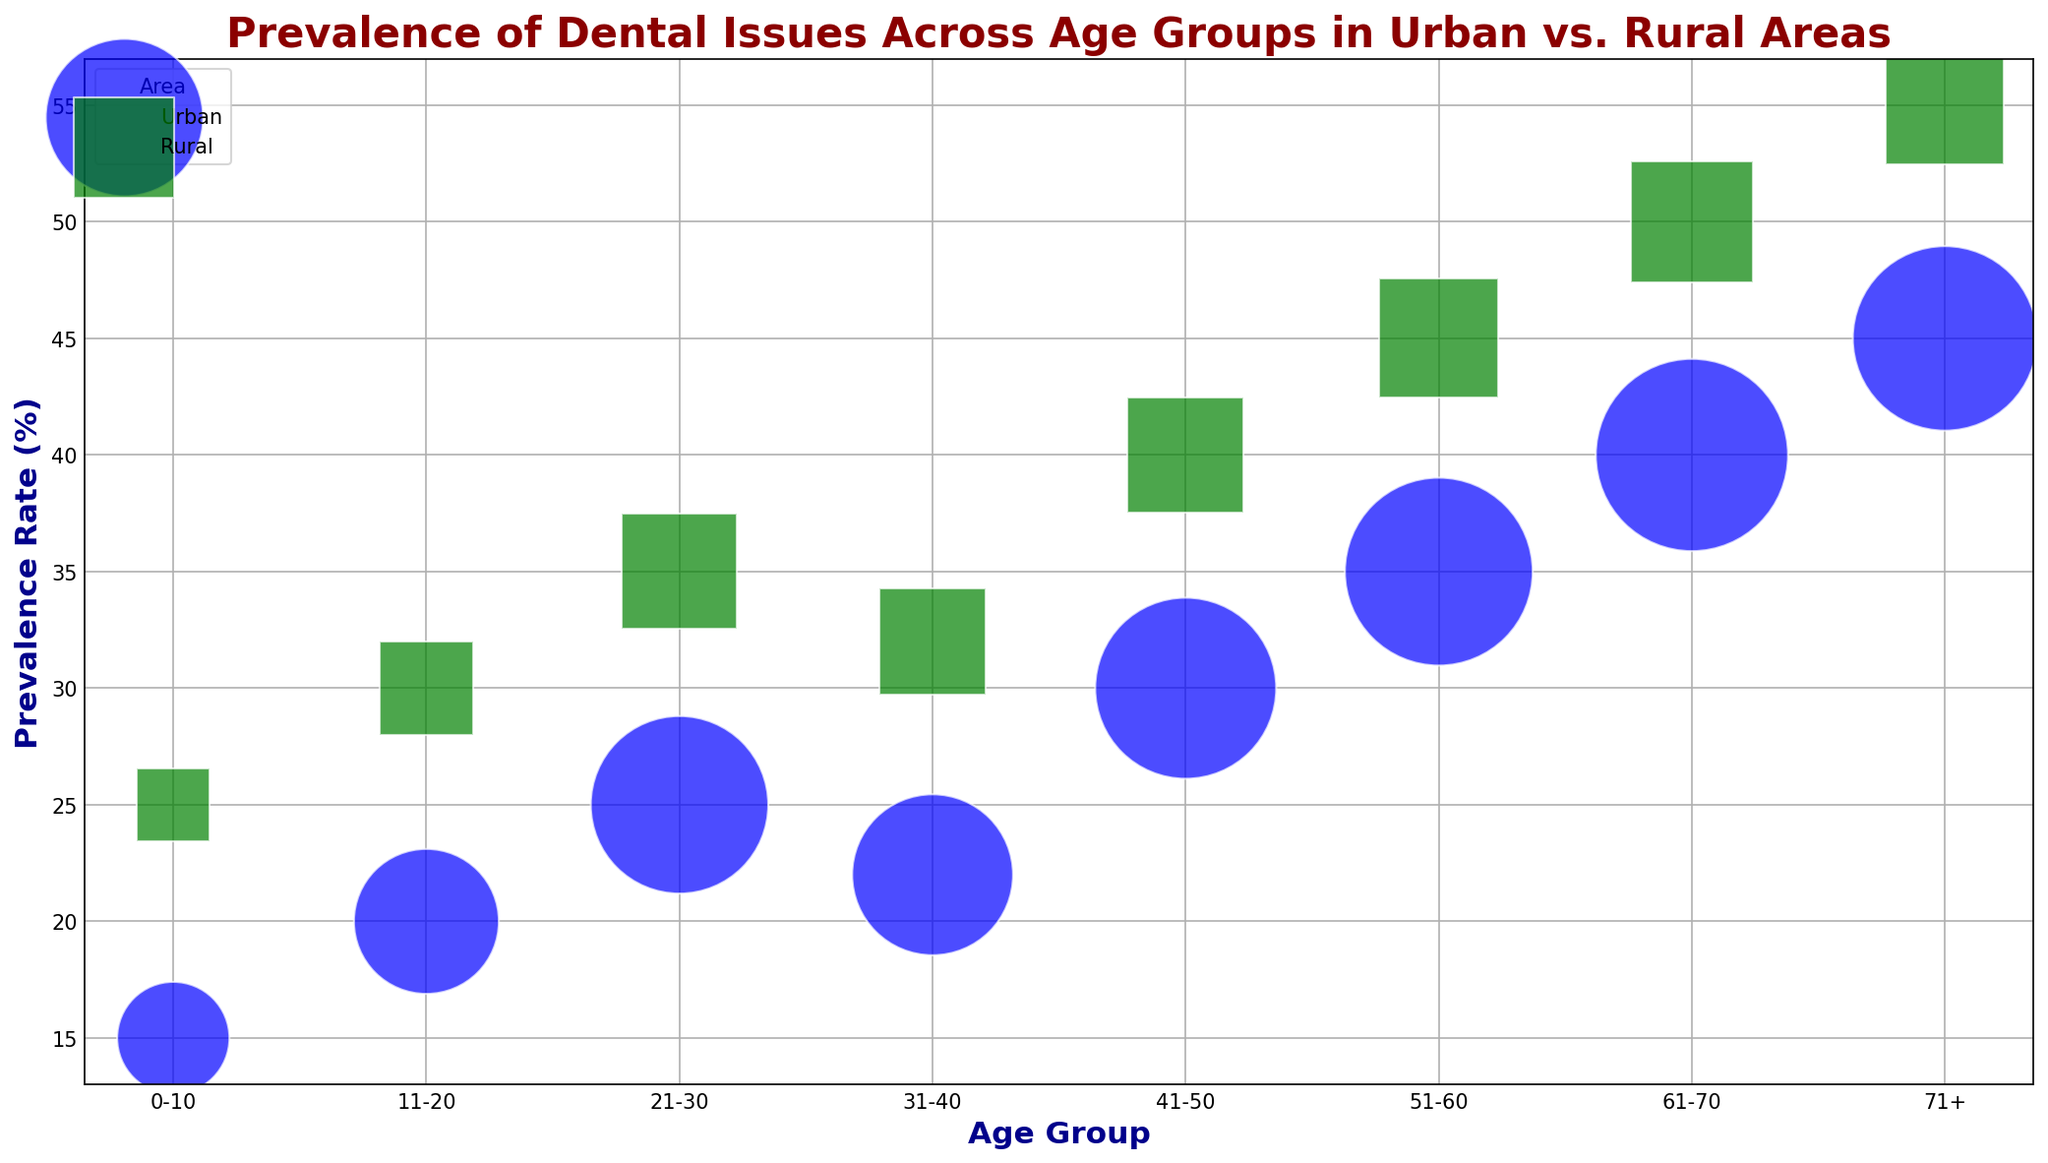Which area has a higher prevalence rate in the 31-40 age group? Compare the prevalence rates of urban and rural areas for the 31-40 age group. Urban has a prevalence rate of 22%, while rural has a prevalence rate of 32%.
Answer: Rural What is the difference in prevalence rate between 0-10 and 61-70 age groups in rural areas? Look at the prevalence rates for rural areas. The 0-10 age group has a prevalence rate of 25%, and the 61-70 age group has a prevalence rate of 50%. The difference is 50% - 25% = 25%.
Answer: 25% Which age group in urban areas has the highest prevalence rate? Examine the prevalence rates of different age groups in urban areas. The highest prevalence rate is 45% for the 71+ age group.
Answer: 71+ How does the bubble size for ages 51-60 compare between urban and rural areas? Check the bubble sizes for the age group of 51-60. Urban has a bubble size of 8400, while rural has a bubble size of 3375. The urban bubble is larger.
Answer: Urban is larger What is the average prevalence rate for urban areas across all age groups? Sum the prevalence rates for urban areas: 15 + 20 + 25 + 22 + 30 + 35 + 40 + 45 = 232. There are 8 age groups, so the average is 232 / 8 = 29%.
Answer: 29% In which area is the prevalence rate consistently higher across all age groups? Compare the prevalence rates for each age group between urban and rural areas. Each rural age group has a higher prevalence rate than its urban counterpart.
Answer: Rural What is the total prevalence rate of the 21-30 age group combining both urban and rural areas? Add the prevalence rates of the 21-30 age group for both areas: Urban 25%, Rural 35%. Total = 25% + 35% = 60%.
Answer: 60% What trend can be observed in the prevalence rate as age increases in urban areas? Examine the prevalence rates in urban areas from youngest to oldest age groups. The trend shows an increase: 15%, 20%, 25%, 22%, 30%, 35%, 40%, and 45%.
Answer: Increasing Which age group has the smallest bubble size in rural areas? Look for the smallest bubble size in the rural area data. The 0-10 age group has the smallest bubble size of 1250.
Answer: 0-10 How much larger is the bubble size for 41-50 age group in urban areas compared to rural areas? Check the bubble sizes for the 41-50 age group. Urban has a bubble size of 7800, and rural has a bubble size of 3200. The difference is 7800 - 3200 = 4600.
Answer: 4600 